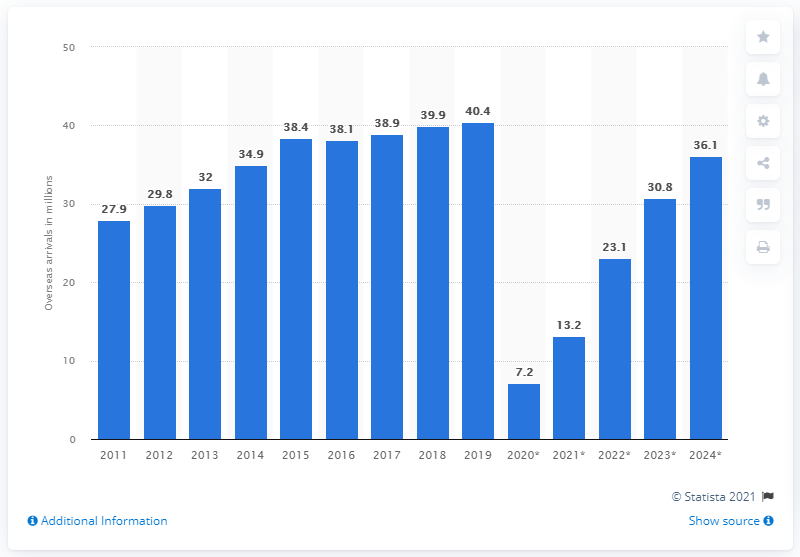List a handful of essential elements in this visual. The number of overseas arrivals to the United States from 2011 to 2019 peaked at 40.4 million. According to estimates, the number of overseas arrivals to the United States is projected to reach 36.1 million by 2024. The projected number of overseas arrivals to the United States in 2020 was 7.2 million. 